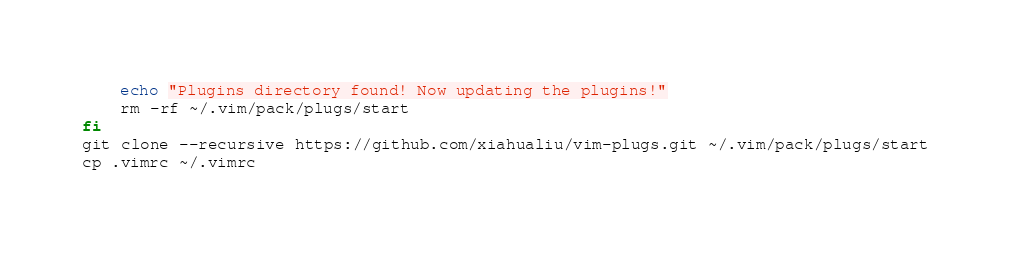Convert code to text. <code><loc_0><loc_0><loc_500><loc_500><_Bash_>	echo "Plugins directory found! Now updating the plugins!"
	rm -rf ~/.vim/pack/plugs/start 
fi
git clone --recursive https://github.com/xiahualiu/vim-plugs.git ~/.vim/pack/plugs/start
cp .vimrc ~/.vimrc
</code> 